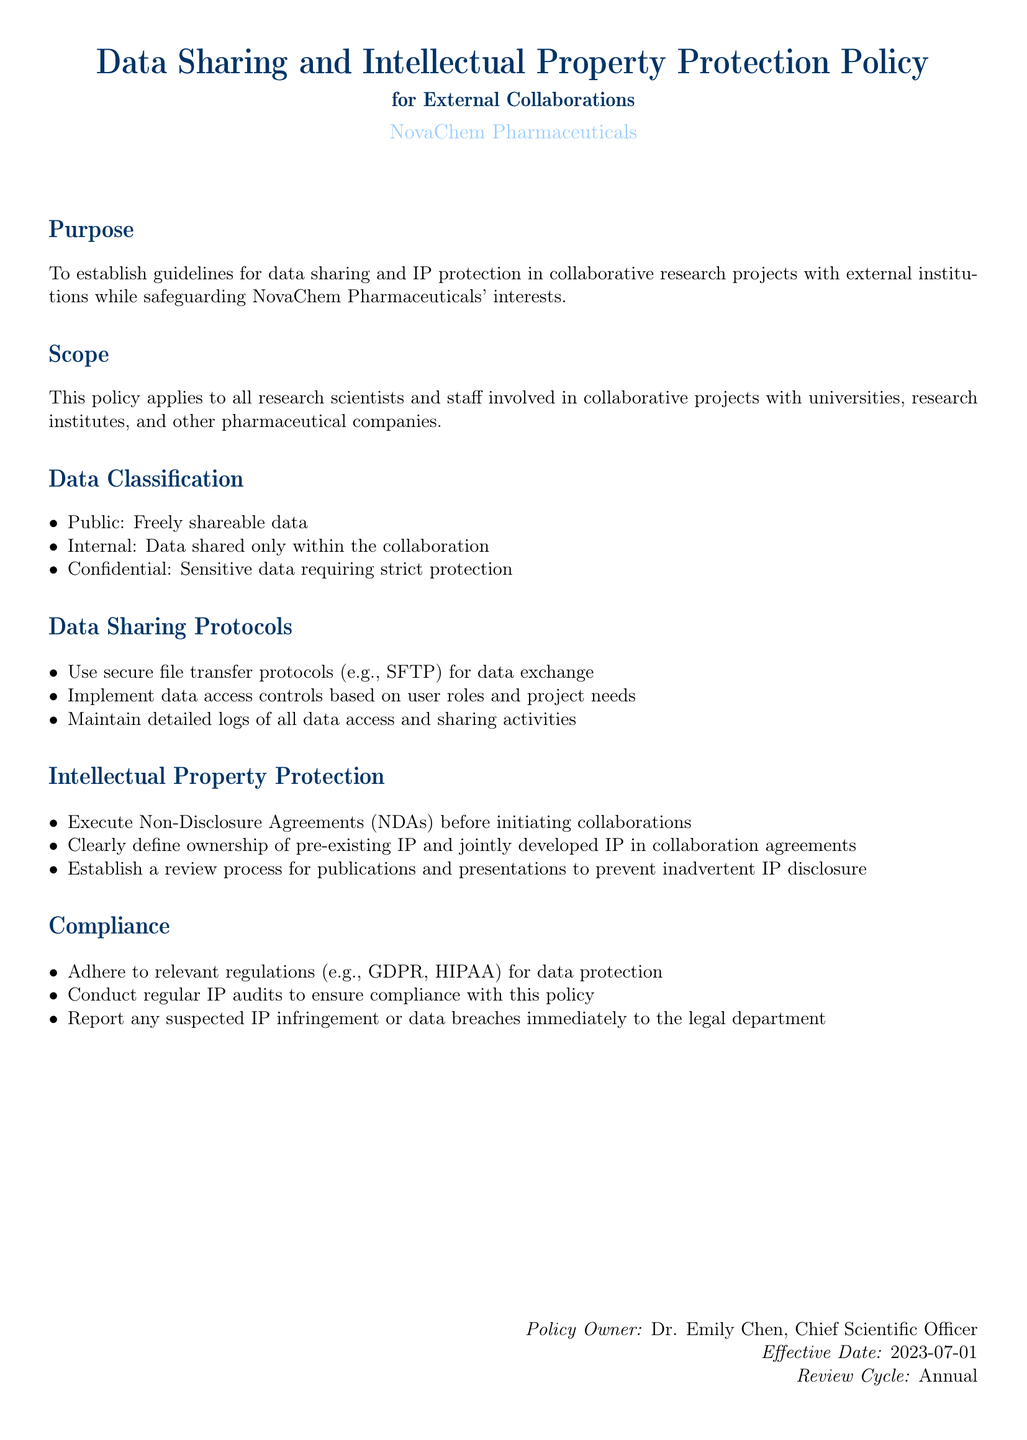What is the purpose of the policy? The purpose of the policy is to establish guidelines for data sharing and IP protection in collaborative research projects while safeguarding interests.
Answer: To establish guidelines for data sharing and IP protection Who is the policy owner? The policy owner is mentioned at the end of the document as the person responsible for the policy.
Answer: Dr. Emily Chen What date did the policy become effective? The effective date is provided in the document as the date when the policy came into force.
Answer: 2023-07-01 What types of data are classified in the document? The document outlines three categories of data classification that are important for collaboration.
Answer: Public, Internal, Confidential What are the data sharing protocols mentioned? The protocols for data sharing are security measures and procedures outlined to protect data during exchange.
Answer: Use secure file transfer protocols, Implement data access controls, Maintain detailed logs How often is the policy reviewed? The review cycle indicates how frequently the policy will be evaluated and updated, if necessary.
Answer: Annual What must be executed before collaborating? The requirement that must be fulfilled prior to beginning collaborations is outlined clearly in the policy.
Answer: Non-Disclosure Agreements (NDAs) What regulations must be adhered to for compliance? The document mentions specific regulations that need to be followed to ensure compliance with data protection norms.
Answer: GDPR, HIPAA What must be reported immediately to the legal department? The document specifies crucial incidents that require immediate reporting to safeguard the company's interests.
Answer: Suspected IP infringement or data breaches 